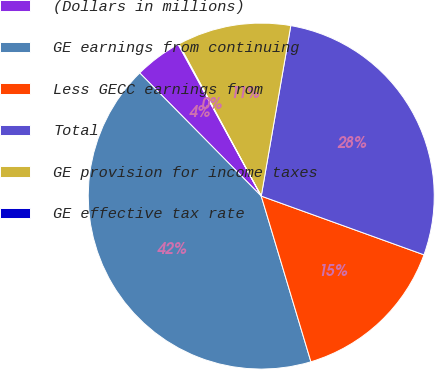Convert chart to OTSL. <chart><loc_0><loc_0><loc_500><loc_500><pie_chart><fcel>(Dollars in millions)<fcel>GE earnings from continuing<fcel>Less GECC earnings from<fcel>Total<fcel>GE provision for income taxes<fcel>GE effective tax rate<nl><fcel>4.42%<fcel>42.24%<fcel>14.85%<fcel>27.78%<fcel>10.63%<fcel>0.08%<nl></chart> 